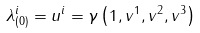Convert formula to latex. <formula><loc_0><loc_0><loc_500><loc_500>\lambda ^ { i } _ { ( 0 ) } = u ^ { i } = \gamma \left ( 1 , v ^ { 1 } , v ^ { 2 } , v ^ { 3 } \right )</formula> 